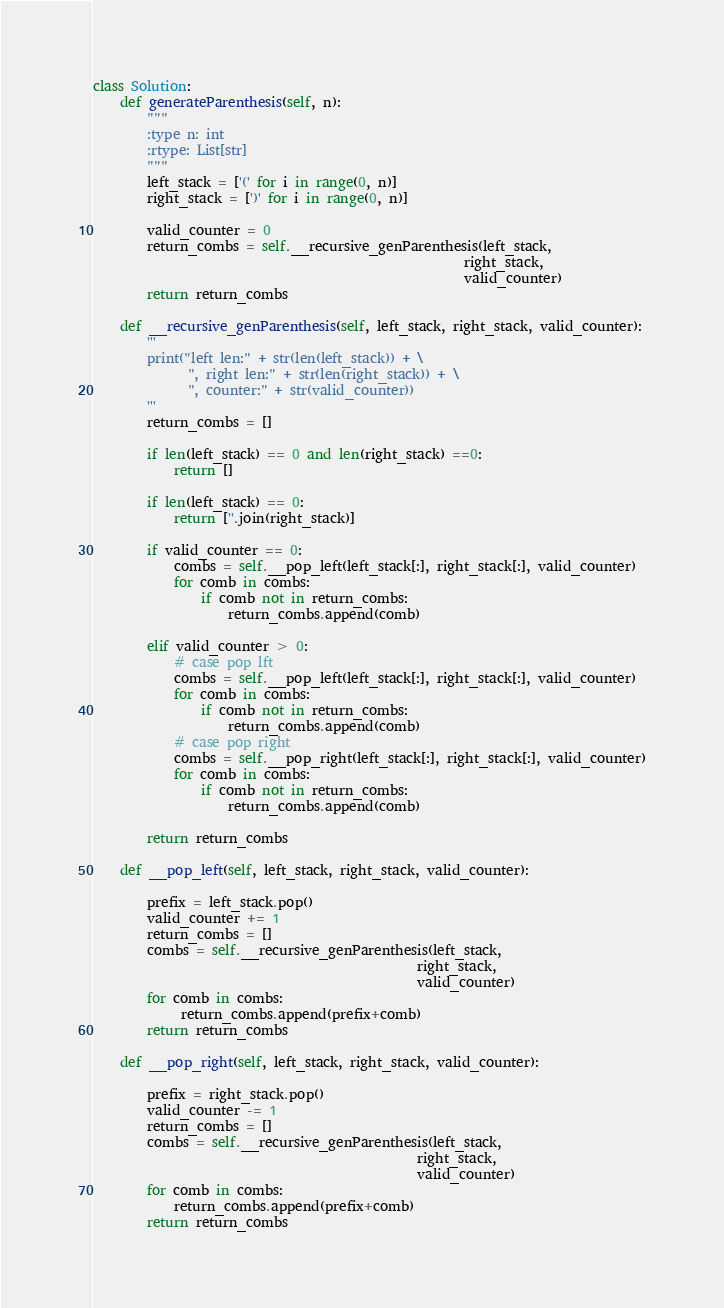Convert code to text. <code><loc_0><loc_0><loc_500><loc_500><_Python_>class Solution:
    def generateParenthesis(self, n):
        """
        :type n: int
        :rtype: List[str]
        """
        left_stack = ['(' for i in range(0, n)]
        right_stack = [')' for i in range(0, n)]

        valid_counter = 0
        return_combs = self.__recursive_genParenthesis(left_stack, 
                                                       right_stack, 
                                                       valid_counter)
        return return_combs

    def __recursive_genParenthesis(self, left_stack, right_stack, valid_counter):
        '''
        print("left len:" + str(len(left_stack)) + \
              ", right len:" + str(len(right_stack)) + \
              ", counter:" + str(valid_counter))
        '''
        return_combs = []

        if len(left_stack) == 0 and len(right_stack) ==0:
            return []

        if len(left_stack) == 0:
            return [''.join(right_stack)]

        if valid_counter == 0:
            combs = self.__pop_left(left_stack[:], right_stack[:], valid_counter)
            for comb in combs:
                if comb not in return_combs:
                    return_combs.append(comb)

        elif valid_counter > 0:
            # case pop lft
            combs = self.__pop_left(left_stack[:], right_stack[:], valid_counter)
            for comb in combs:
                if comb not in return_combs:
                    return_combs.append(comb)
            # case pop right
            combs = self.__pop_right(left_stack[:], right_stack[:], valid_counter)
            for comb in combs:
                if comb not in return_combs:
                    return_combs.append(comb)

        return return_combs

    def __pop_left(self, left_stack, right_stack, valid_counter):

        prefix = left_stack.pop()
        valid_counter += 1
        return_combs = []
        combs = self.__recursive_genParenthesis(left_stack, 
                                                right_stack, 
                                                valid_counter)
        for comb in combs:
             return_combs.append(prefix+comb)
        return return_combs

    def __pop_right(self, left_stack, right_stack, valid_counter):

        prefix = right_stack.pop()
        valid_counter -= 1
        return_combs = []
        combs = self.__recursive_genParenthesis(left_stack, 
                                                right_stack, 
                                                valid_counter)
        for comb in combs:
            return_combs.append(prefix+comb)
        return return_combs
</code> 